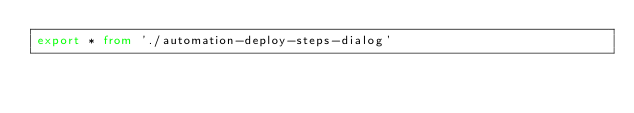<code> <loc_0><loc_0><loc_500><loc_500><_TypeScript_>export * from './automation-deploy-steps-dialog'
</code> 